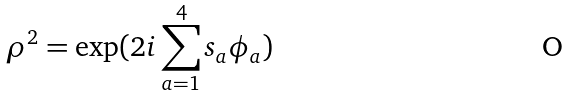<formula> <loc_0><loc_0><loc_500><loc_500>\rho ^ { 2 } = \exp ( 2 i \sum _ { a = 1 } ^ { 4 } s _ { a } \phi _ { a } )</formula> 